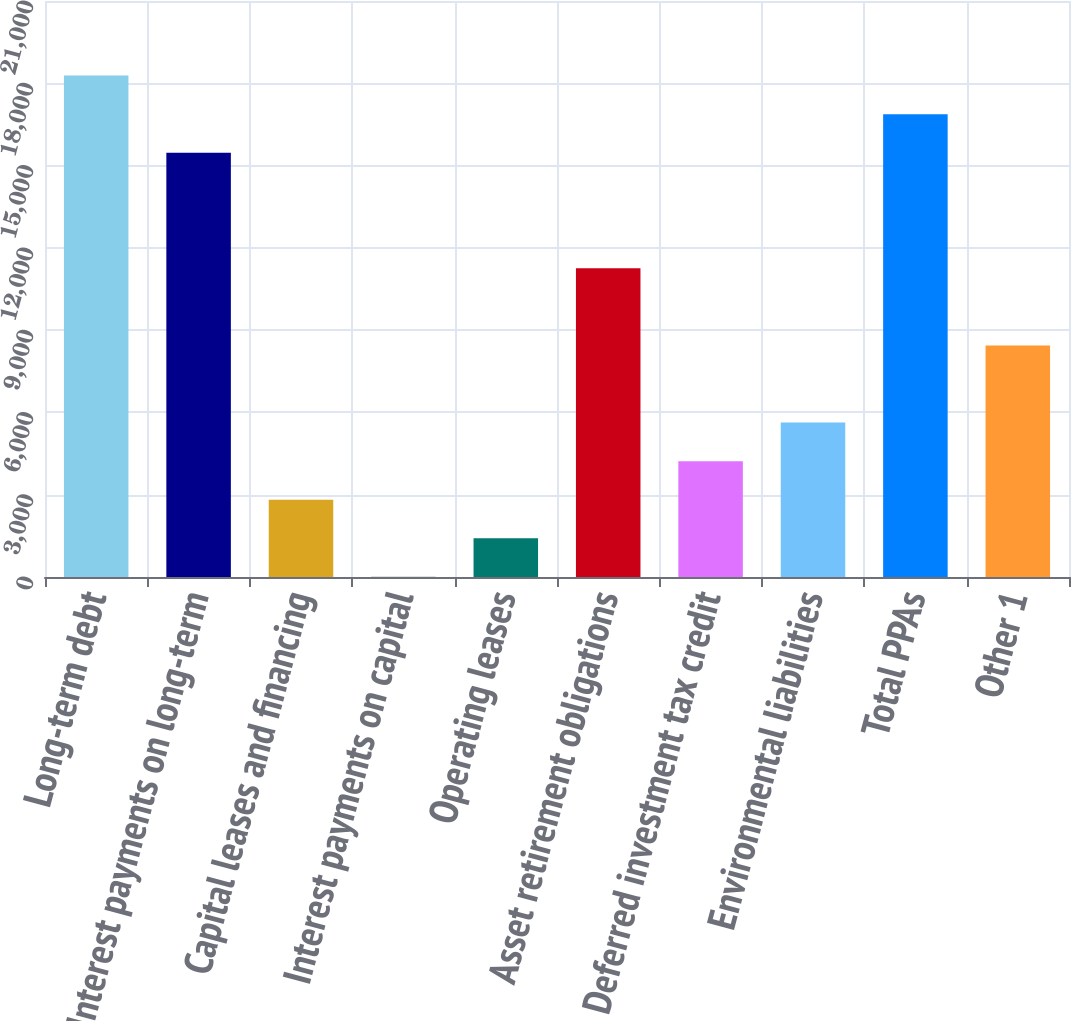<chart> <loc_0><loc_0><loc_500><loc_500><bar_chart><fcel>Long-term debt<fcel>Interest payments on long-term<fcel>Capital leases and financing<fcel>Interest payments on capital<fcel>Operating leases<fcel>Asset retirement obligations<fcel>Deferred investment tax credit<fcel>Environmental liabilities<fcel>Total PPAs<fcel>Other 1<nl><fcel>18281.4<fcel>15469.8<fcel>2817.6<fcel>6<fcel>1411.8<fcel>11252.4<fcel>4223.4<fcel>5629.2<fcel>16875.6<fcel>8440.8<nl></chart> 